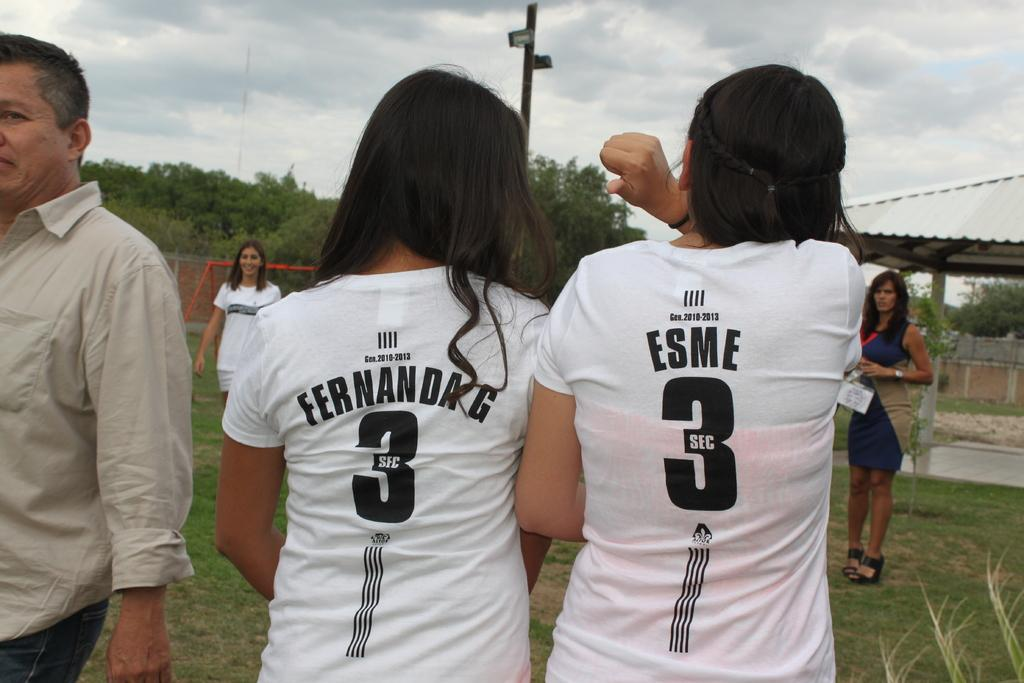<image>
Offer a succinct explanation of the picture presented. Two people standing next to one another with one named ESME. 